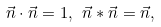<formula> <loc_0><loc_0><loc_500><loc_500>\vec { n } \cdot \vec { n } = 1 , \ \vec { n } * \vec { n } = \vec { n } ,</formula> 